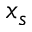Convert formula to latex. <formula><loc_0><loc_0><loc_500><loc_500>x _ { s }</formula> 